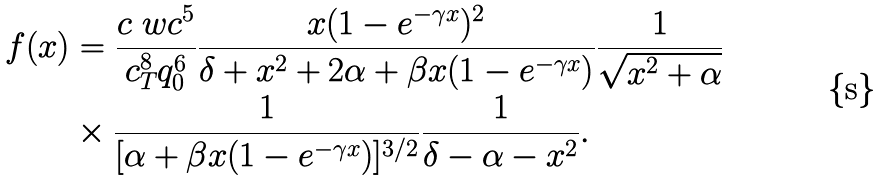<formula> <loc_0><loc_0><loc_500><loc_500>f ( x ) & = \frac { c \ w c ^ { 5 } } { c _ { T } ^ { 8 } q _ { 0 } ^ { 6 } } \frac { x ( 1 - e ^ { - \gamma x } ) ^ { 2 } } { \delta + x ^ { 2 } + 2 \alpha + \beta x ( 1 - e ^ { - \gamma x } ) } \frac { 1 } { \sqrt { x ^ { 2 } + \alpha } } \\ & \times \frac { 1 } { [ \alpha + \beta x ( 1 - e ^ { - \gamma x } ) ] ^ { 3 / 2 } } \frac { 1 } { \delta - \alpha - x ^ { 2 } } .</formula> 